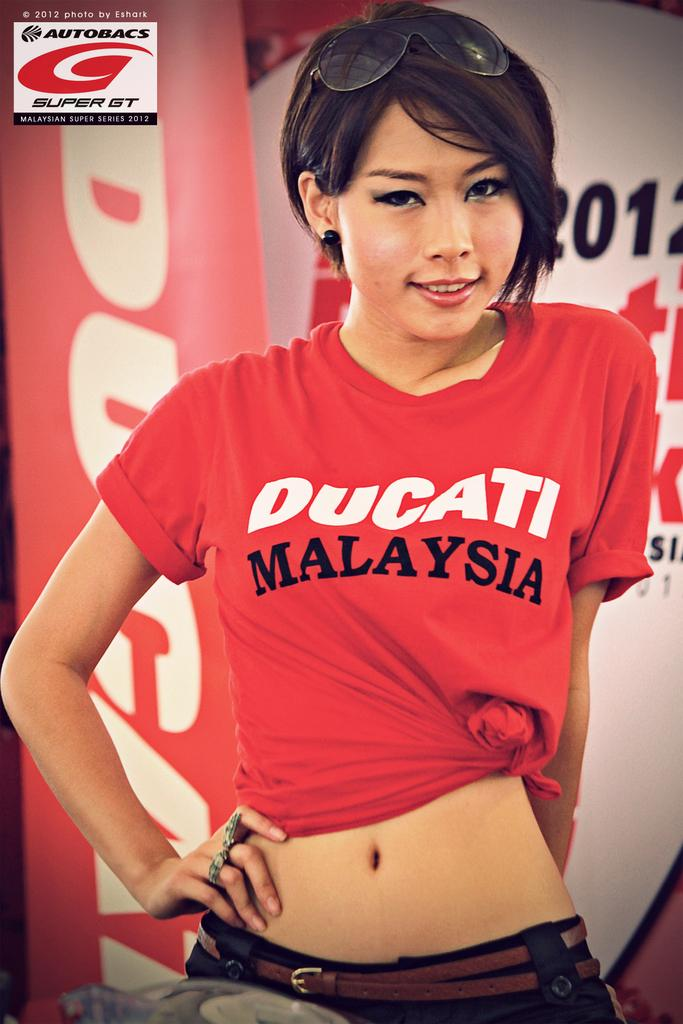<image>
Summarize the visual content of the image. A woman with dark hair wearing a red Ducati Malaysia t-shirt. 